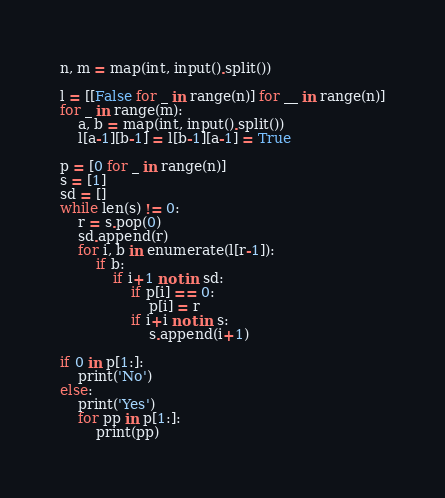<code> <loc_0><loc_0><loc_500><loc_500><_Python_>n, m = map(int, input().split())

l = [[False for _ in range(n)] for __ in range(n)]
for _ in range(m):
    a, b = map(int, input().split())
    l[a-1][b-1] = l[b-1][a-1] = True

p = [0 for _ in range(n)]
s = [1]
sd = []
while len(s) != 0:
    r = s.pop(0)
    sd.append(r)
    for i, b in enumerate(l[r-1]):
        if b:
            if i+1 not in sd:
                if p[i] == 0:
                    p[i] = r
                if i+i not in s:
                    s.append(i+1)

if 0 in p[1:]:
    print('No')
else:
    print('Yes')
    for pp in p[1:]:
        print(pp)</code> 